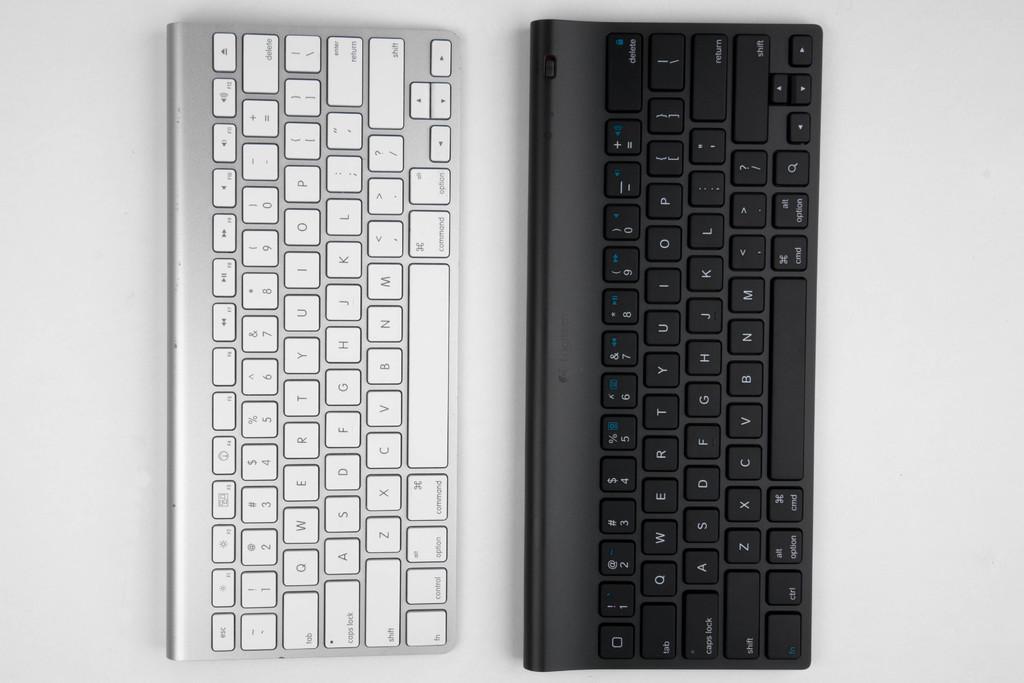What brand is the black keyboard?
Ensure brevity in your answer.  Logitech. 